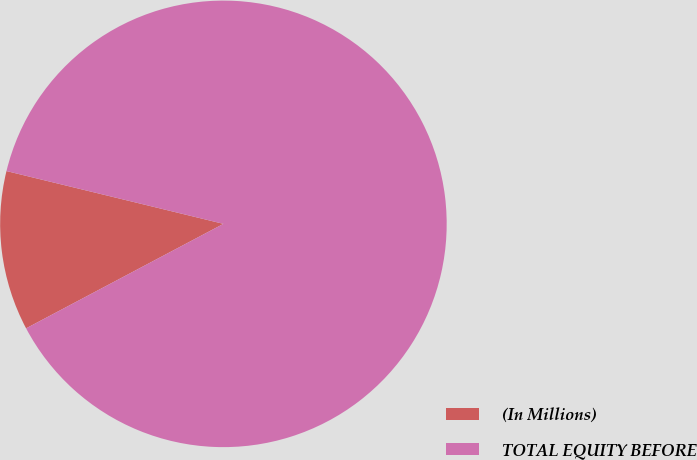Convert chart to OTSL. <chart><loc_0><loc_0><loc_500><loc_500><pie_chart><fcel>(In Millions)<fcel>TOTAL EQUITY BEFORE<nl><fcel>11.55%<fcel>88.45%<nl></chart> 